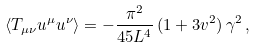Convert formula to latex. <formula><loc_0><loc_0><loc_500><loc_500>\langle T _ { \mu \nu } u ^ { \mu } u ^ { \nu } \rangle = - \frac { \pi ^ { 2 } } { 4 5 L ^ { 4 } } \, ( 1 + 3 v ^ { 2 } ) \, \gamma ^ { 2 } \, ,</formula> 